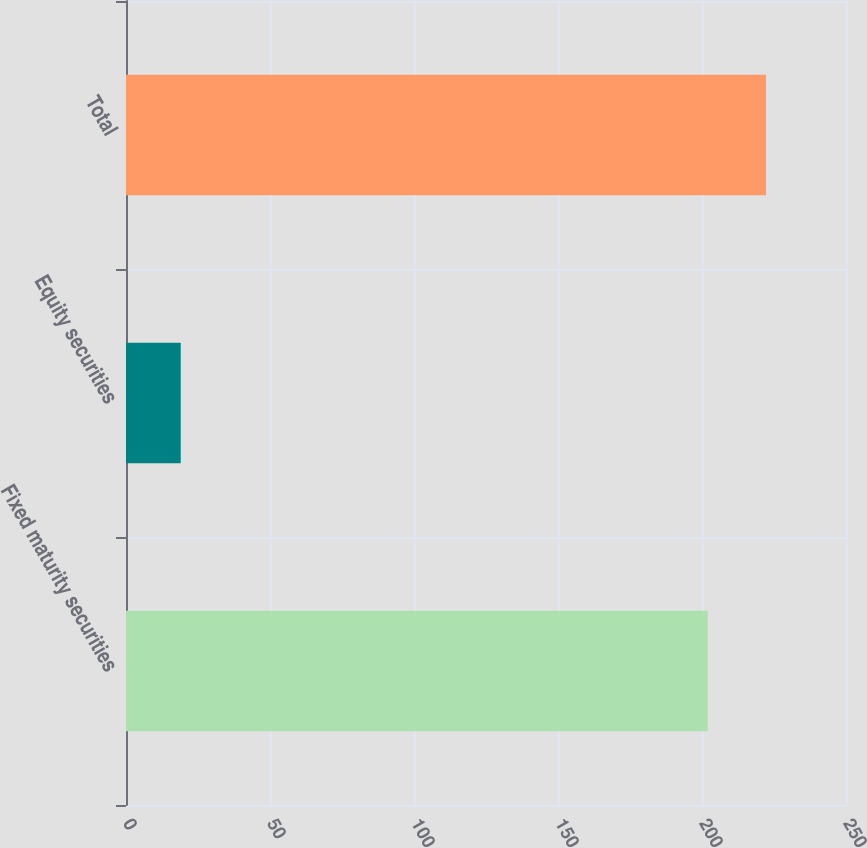Convert chart. <chart><loc_0><loc_0><loc_500><loc_500><bar_chart><fcel>Fixed maturity securities<fcel>Equity securities<fcel>Total<nl><fcel>202<fcel>19<fcel>222.2<nl></chart> 